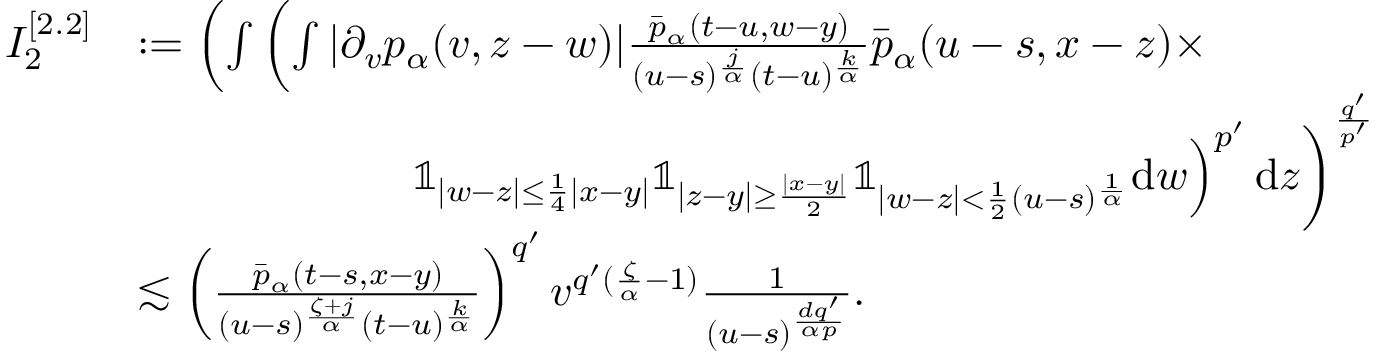Convert formula to latex. <formula><loc_0><loc_0><loc_500><loc_500>\begin{array} { r l } { I _ { 2 } ^ { [ 2 . 2 ] } } & { \colon = \left ( \int \left ( \int | \partial _ { v } p _ { \alpha } ( v , z - w ) | \frac { \bar { p } _ { \alpha } ( t - u , w - y ) } { ( u - s ) ^ { \frac { j } { \alpha } } ( t - u ) ^ { \frac { k } { \alpha } } } \bar { p } _ { \alpha } ( u - s , x - z ) \times } \\ & { \quad \mathbb { 1 } _ { | w - z | \leq \frac { 1 } { 4 } | x - y | } \mathbb { 1 } _ { | z - y | \geq \frac { | x - y | } { 2 } } \mathbb { 1 } _ { | w - z | < \frac { 1 } { 2 } ( u - s ) ^ { \frac { 1 } { \alpha } } } d w \right ) ^ { p ^ { \prime } } d z \right ) ^ { \frac { q ^ { \prime } } { p ^ { \prime } } } } \\ & { \lesssim \left ( \frac { \bar { p } _ { \alpha } ( t - s , x - y ) } { ( u - s ) ^ { \frac { \zeta + j } { \alpha } } ( t - u ) ^ { \frac { k } { \alpha } } } \right ) ^ { q ^ { \prime } } v ^ { q ^ { \prime } ( \frac { \zeta } { \alpha } - 1 ) } \frac { 1 } { ( u - s ) ^ { \frac { d q ^ { \prime } } { \alpha p } } } . } \end{array}</formula> 